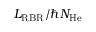<formula> <loc_0><loc_0><loc_500><loc_500>L _ { R B R } / \hbar { N } _ { H e }</formula> 